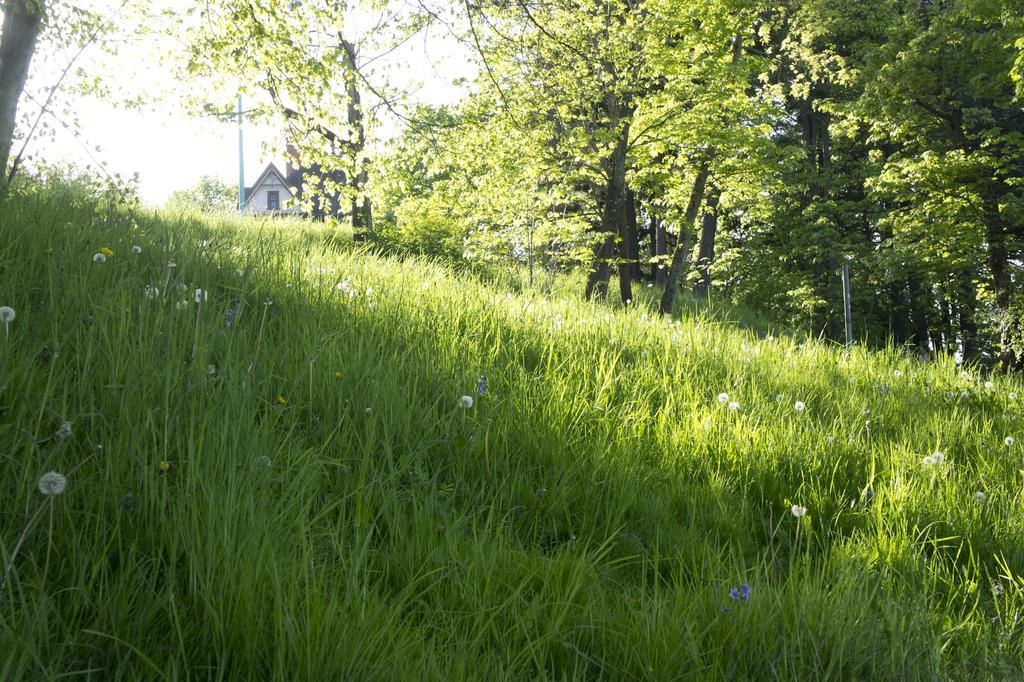In one or two sentences, can you explain what this image depicts? In this image I can see grass, number of trees, a pole and a house. 